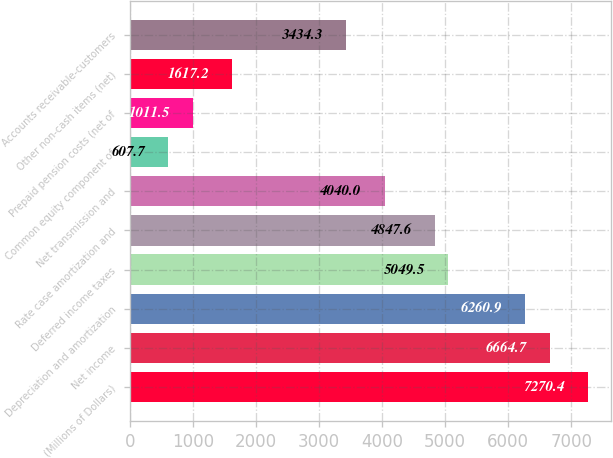Convert chart to OTSL. <chart><loc_0><loc_0><loc_500><loc_500><bar_chart><fcel>(Millions of Dollars)<fcel>Net income<fcel>Depreciation and amortization<fcel>Deferred income taxes<fcel>Rate case amortization and<fcel>Net transmission and<fcel>Common equity component of<fcel>Prepaid pension costs (net of<fcel>Other non-cash items (net)<fcel>Accounts receivable-customers<nl><fcel>7270.4<fcel>6664.7<fcel>6260.9<fcel>5049.5<fcel>4847.6<fcel>4040<fcel>607.7<fcel>1011.5<fcel>1617.2<fcel>3434.3<nl></chart> 